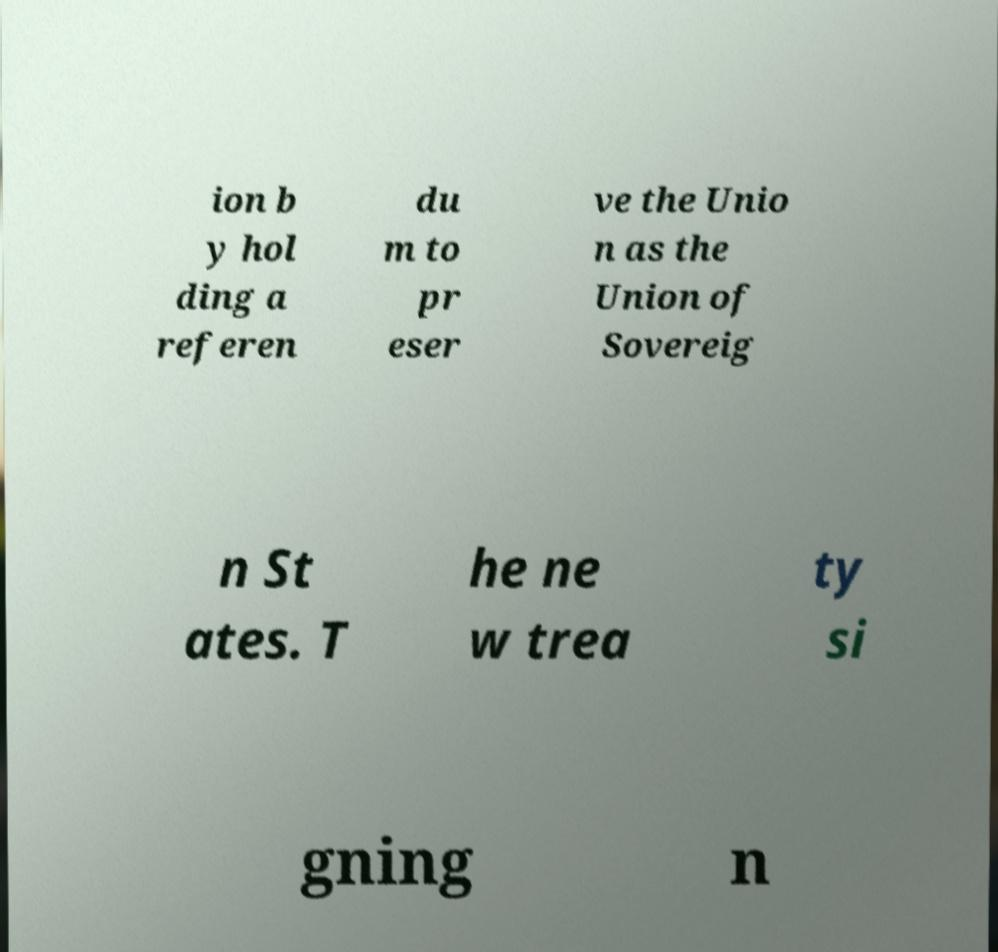Could you assist in decoding the text presented in this image and type it out clearly? ion b y hol ding a referen du m to pr eser ve the Unio n as the Union of Sovereig n St ates. T he ne w trea ty si gning n 